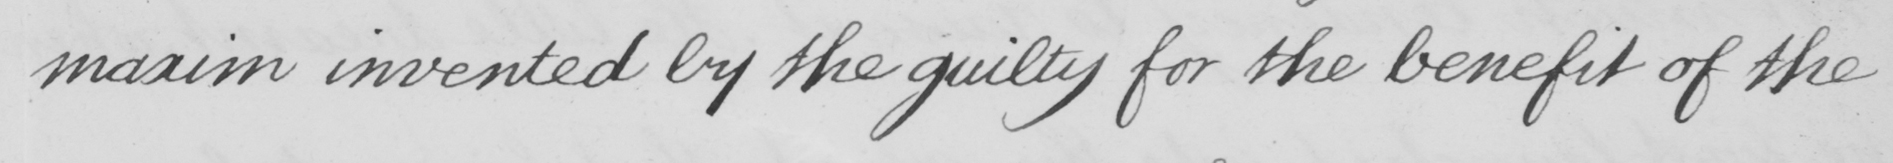Please transcribe the handwritten text in this image. maxim invented by the guilty for the benefit of the 